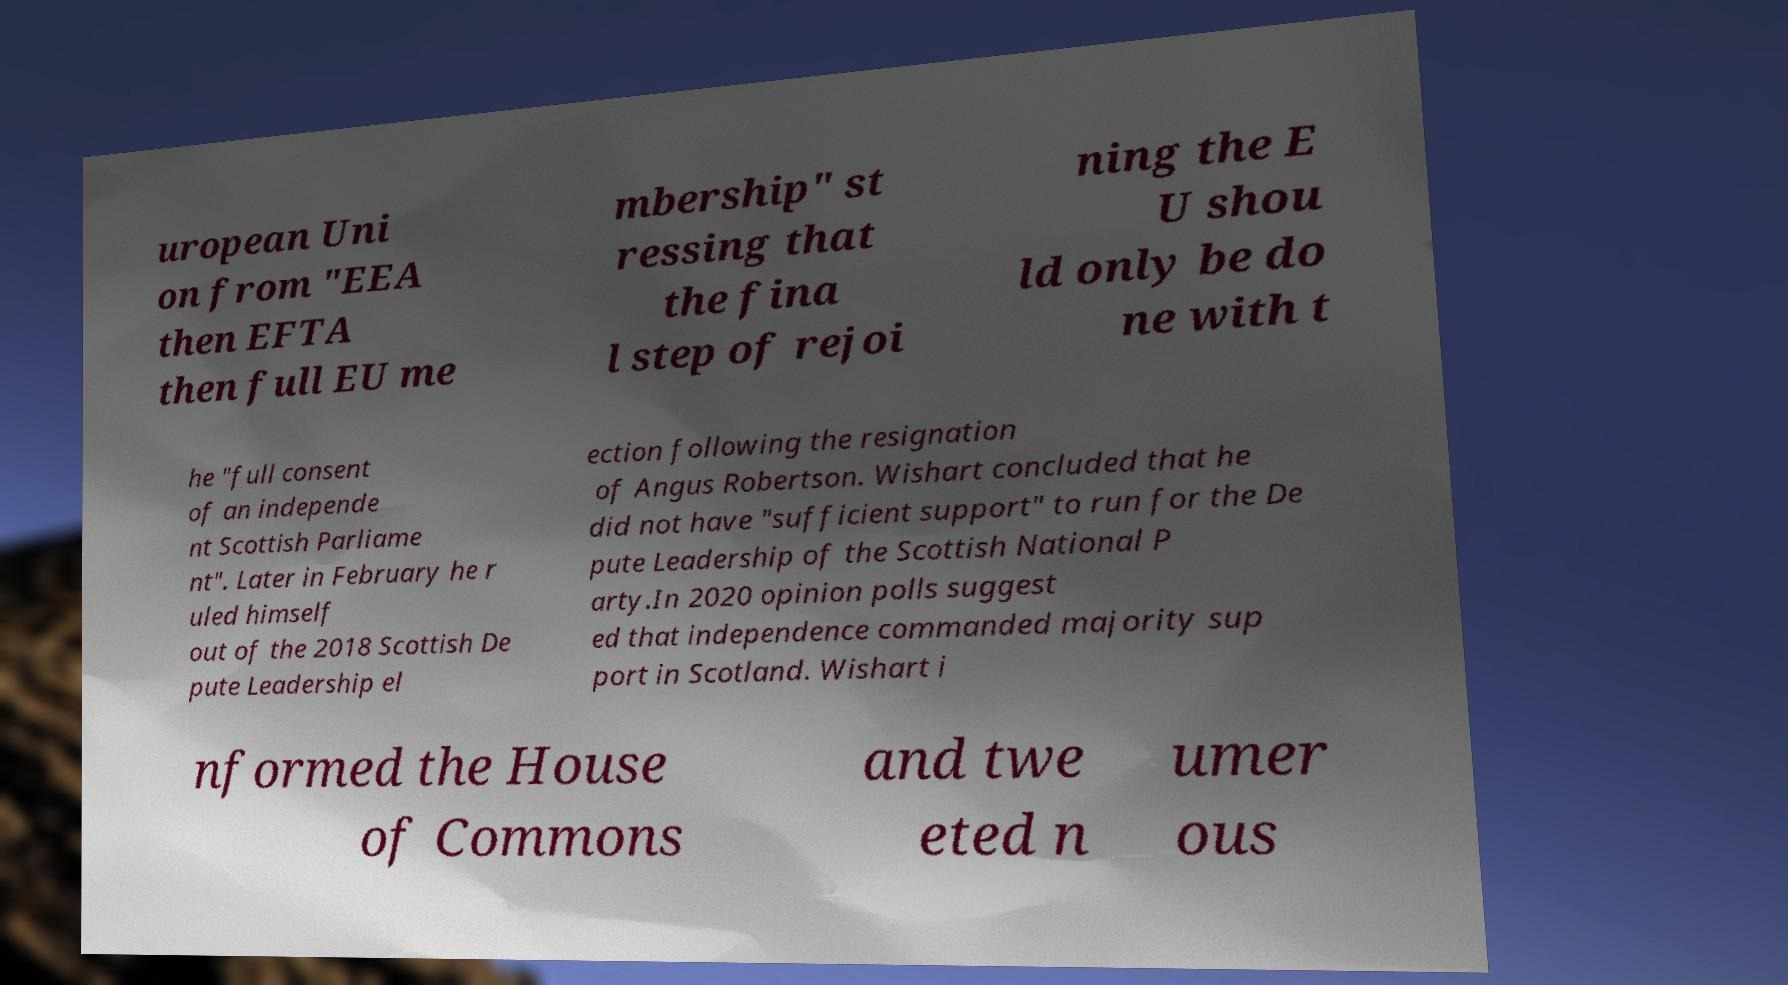There's text embedded in this image that I need extracted. Can you transcribe it verbatim? uropean Uni on from "EEA then EFTA then full EU me mbership" st ressing that the fina l step of rejoi ning the E U shou ld only be do ne with t he "full consent of an independe nt Scottish Parliame nt". Later in February he r uled himself out of the 2018 Scottish De pute Leadership el ection following the resignation of Angus Robertson. Wishart concluded that he did not have "sufficient support" to run for the De pute Leadership of the Scottish National P arty.In 2020 opinion polls suggest ed that independence commanded majority sup port in Scotland. Wishart i nformed the House of Commons and twe eted n umer ous 